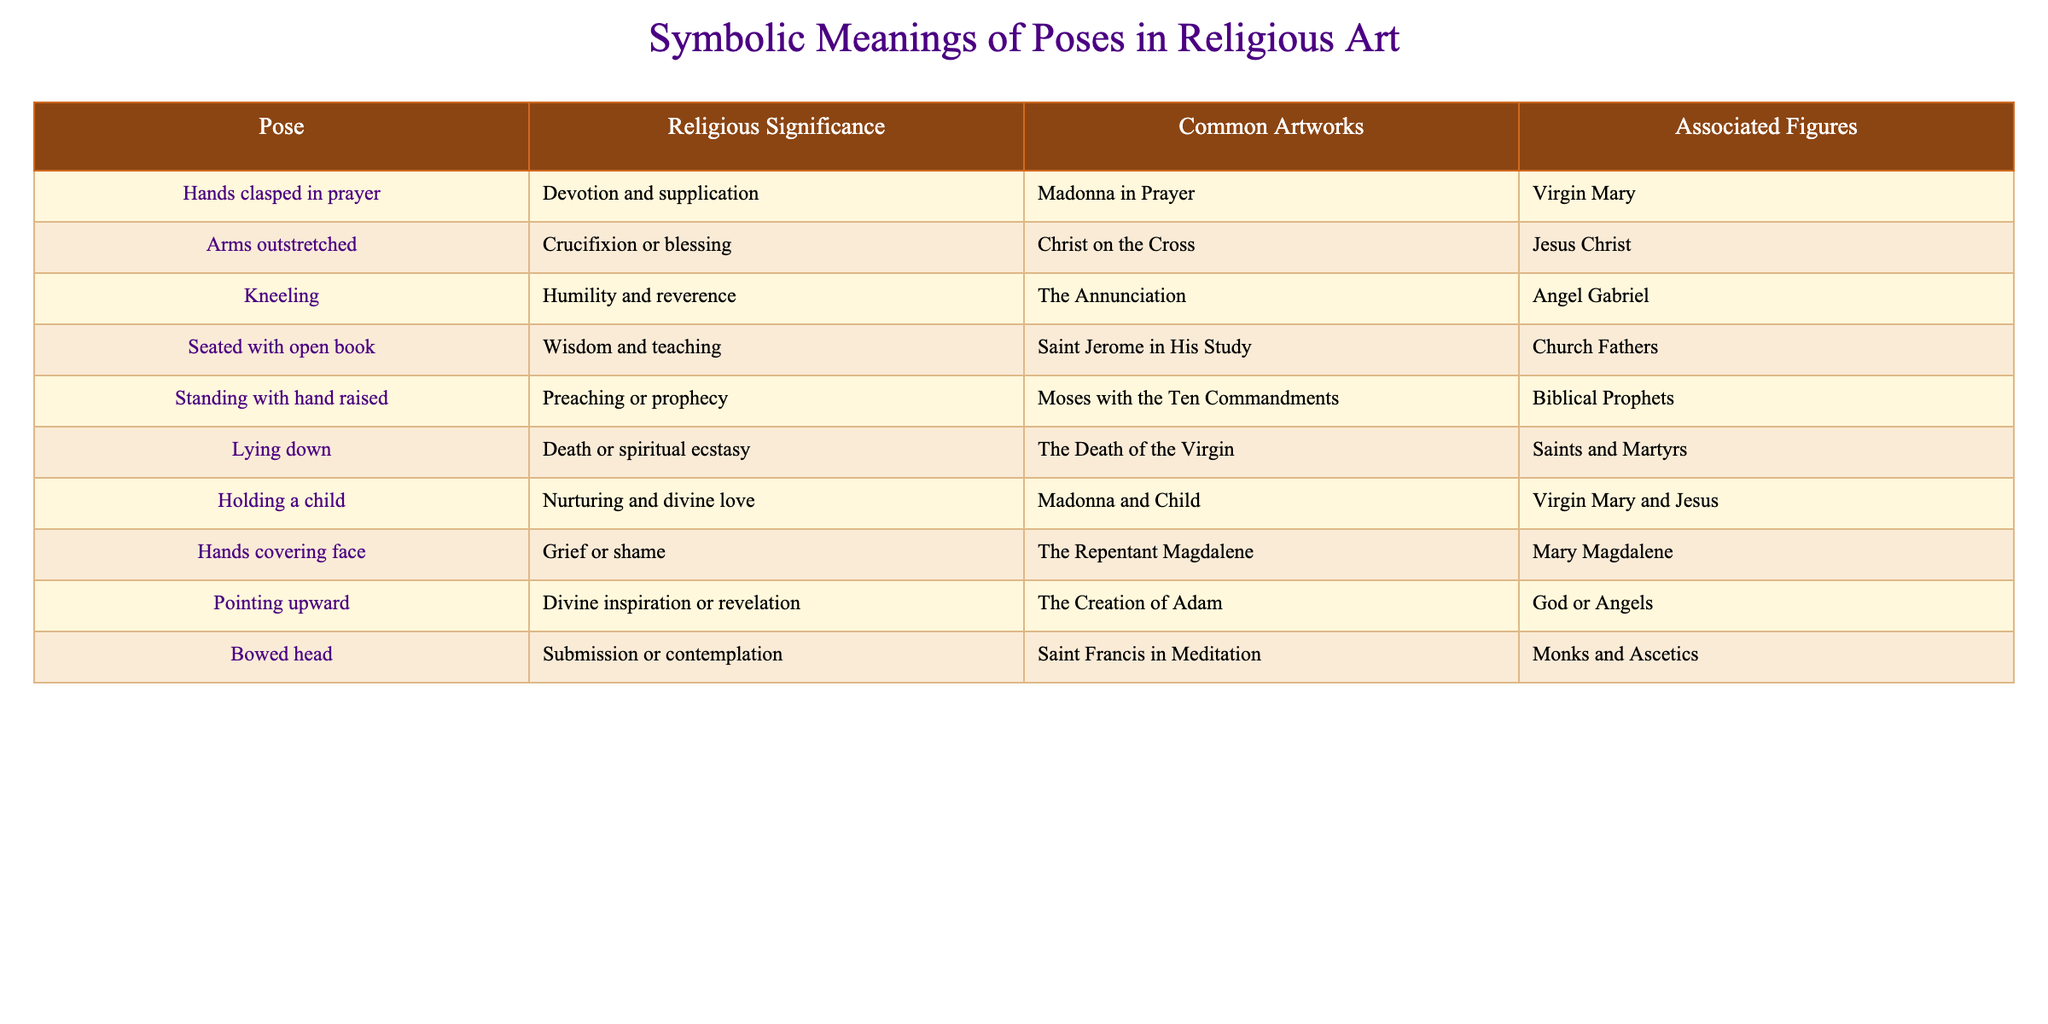What does the pose of hands clasped in prayer signify? According to the table, "Hands clasped in prayer" signifies devotion and supplication.
Answer: Devotion and supplication Which pose is associated with the figure of Mary Magdalene? The table shows that the pose "Hands covering face" is associated with Mary Magdalene.
Answer: Hands covering face How many poses represent aspects of nurturing or motherhood? By checking the table, we find that only one pose, "Holding a child," represents nurturing and divine love, associated with the figures of Virgin Mary and Jesus.
Answer: One pose Is there any pose that signifies both spiritual ecstasy and death? The table indicates that the pose "Lying down" is associated with death or spiritual ecstasy. Therefore, the answer is yes.
Answer: Yes Which pose is common in the artwork of "Christ on the Cross"? Referring to the table, the pose associated with "Christ on the Cross" is "Arms outstretched."
Answer: Arms outstretched What are two poses associated with Virgin Mary in religious art? The table lists "Hands clasped in prayer" and "Holding a child" as poses associated with Virgin Mary, showing devotion and nurturing.
Answer: Hands clasped in prayer and Holding a child If a figure is depicted kneeling, what does it represent? According to the table, the pose "Kneeling" represents humility and reverence in religious art.
Answer: Humility and reverence How many poses indicating submission or contemplation are in the table? The table shows there is one pose that indicates submission or contemplation: "Bowed head."
Answer: One pose Is the pose of "Standing with hand raised" linked to any figures other than Biblical Prophets? Looking at the table, "Standing with hand raised" is specifically linked to the figure of Biblical Prophets only.
Answer: No What is the significance of the pose "Pointing upward"? The table indicates that "Pointing upward" signifies divine inspiration or revelation in religious art.
Answer: Divine inspiration or revelation Which pose appears in the artwork "The Annunciation"? Referring to the table, "Kneeling" is the pose that appears in "The Annunciation."
Answer: Kneeling 